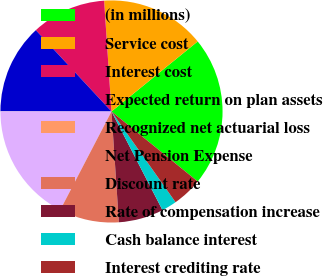Convert chart. <chart><loc_0><loc_0><loc_500><loc_500><pie_chart><fcel>(in millions)<fcel>Service cost<fcel>Interest cost<fcel>Expected return on plan assets<fcel>Recognized net actuarial loss<fcel>Net Pension Expense<fcel>Discount rate<fcel>Rate of compensation increase<fcel>Cash balance interest<fcel>Interest crediting rate<nl><fcel>21.71%<fcel>15.2%<fcel>10.87%<fcel>13.04%<fcel>0.02%<fcel>17.37%<fcel>8.7%<fcel>6.53%<fcel>2.19%<fcel>4.36%<nl></chart> 